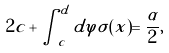Convert formula to latex. <formula><loc_0><loc_0><loc_500><loc_500>2 c + \int _ { c } ^ { d } d \varphi \tilde { \sigma } ( x ) = \frac { \alpha } { 2 } ,</formula> 